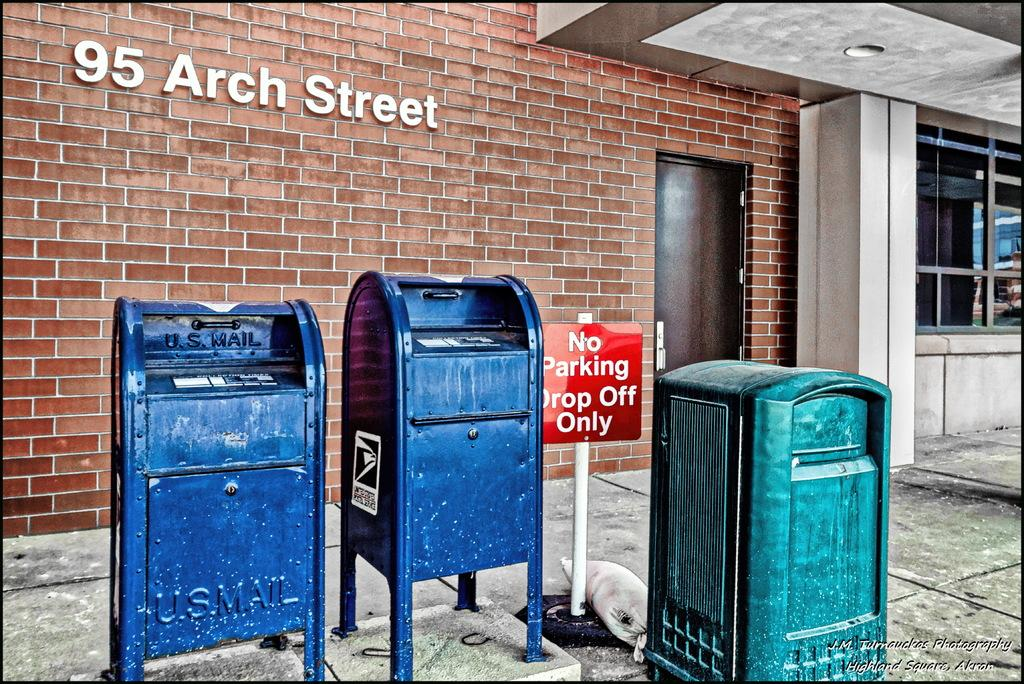Provide a one-sentence caption for the provided image. U.S Mail postal boxes outside on 95 arch street. 